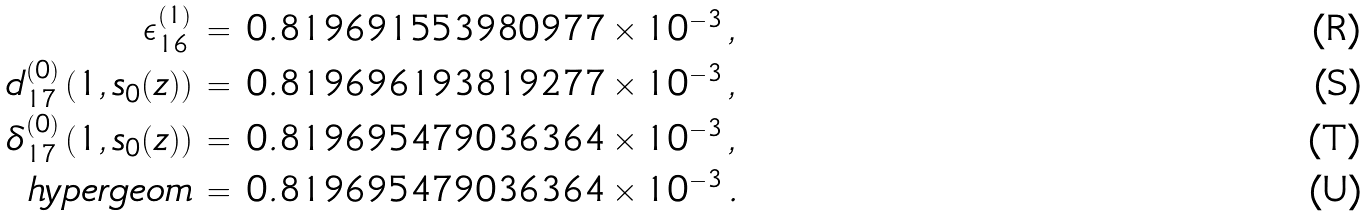<formula> <loc_0><loc_0><loc_500><loc_500>\epsilon _ { 1 6 } ^ { ( 1 ) } & \, = \, 0 . 8 1 9 6 9 1 5 5 3 9 8 0 9 7 7 \times 1 0 ^ { - 3 } \, , \\ d _ { 1 7 } ^ { ( 0 ) } \left ( 1 , s _ { 0 } ( z ) \right ) & \, = \, 0 . 8 1 9 6 9 6 1 9 3 8 1 9 2 7 7 \times 1 0 ^ { - 3 } \, , \\ { \delta } _ { 1 7 } ^ { ( 0 ) } \left ( 1 , s _ { 0 } ( z ) \right ) & \, = \, 0 . 8 1 9 6 9 5 4 7 9 0 3 6 3 6 4 \times 1 0 ^ { - 3 } \, , \\ h y p e r g e o m & \, = \, 0 . 8 1 9 6 9 5 4 7 9 0 3 6 3 6 4 \times 1 0 ^ { - 3 } \, .</formula> 